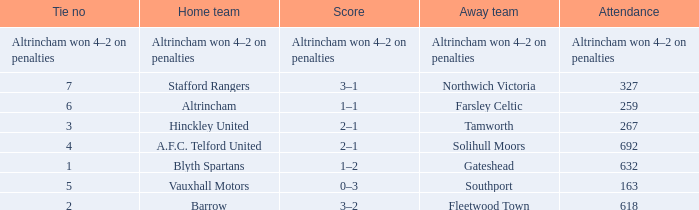Which away team that had a tie of 7? Northwich Victoria. 